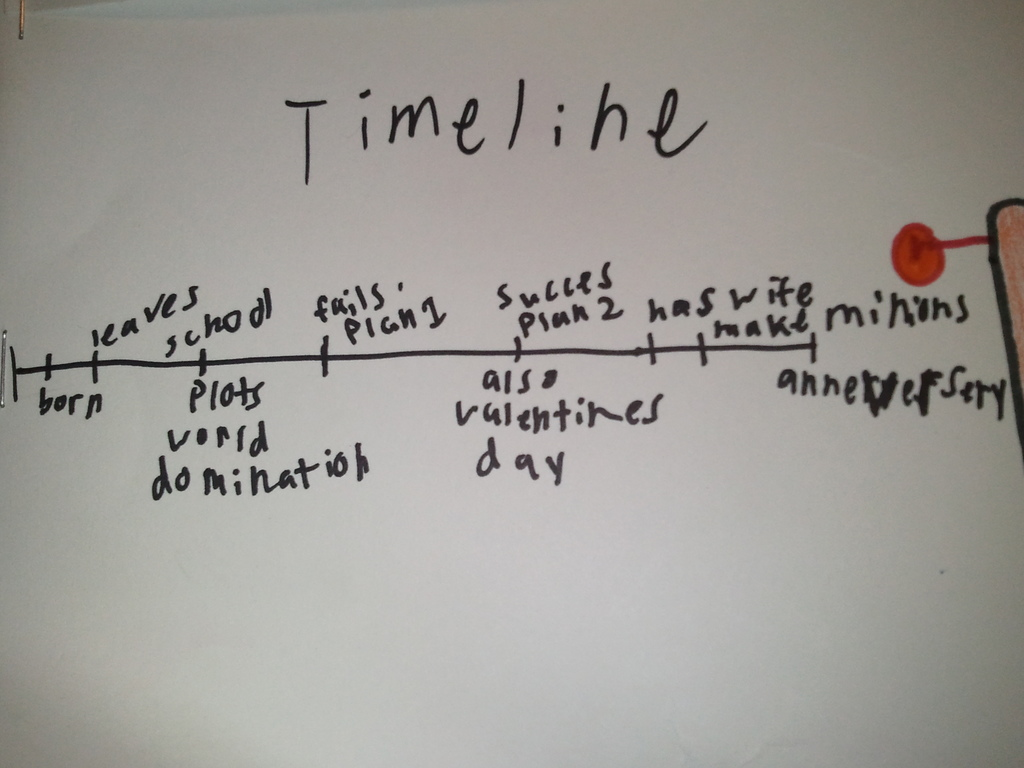Can you tell me the story behind the “plots world domination” entry on this timeline? The 'plots world domination' entry, depicted with whimsy on this timeline, suggests a moment of ambitious goal-setting by the timeline's creator. This facetious event likely represents a turning point of dreaming big or embracing one's aspirations, regardless of their grandiosity. As it's followed by 'fails plan,' it could also emphasize the idea that even if one doesn’t initially succeed, perseverance is key, as shown by the subsequent 'success plan 2' which humorously claims the achievement of that lofty goal. 